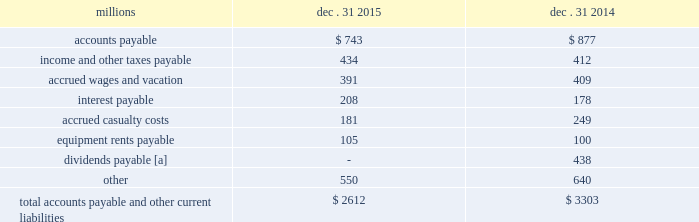Appropriate statistical bases .
Total expense for repairs and maintenance incurred was $ 2.5 billion for 2015 , $ 2.4 billion for 2014 , and $ 2.3 billion for 2013 .
Assets held under capital leases are recorded at the lower of the net present value of the minimum lease payments or the fair value of the leased asset at the inception of the lease .
Amortization expense is computed using the straight-line method over the shorter of the estimated useful lives of the assets or the period of the related lease .
13 .
Accounts payable and other current liabilities dec .
31 , dec .
31 , millions 2015 2014 .
[a] beginning in 2015 , the timing of the dividend declaration and payable dates was aligned to occur within the same quarter .
The 2015 dividends paid amount includes the fourth quarter 2014 dividend of $ 438 million , which was paid on january 2 , 2015 , the first quarter 2015 dividend of $ 484 million , which was paid on march 30 , 2015 , the second quarter 2015 dividend of $ 479 million , which was paid on june 30 , 2015 , the third quarter 2015 dividend of $ 476 million , which was paid on september 30 , 2015 , as well as the fourth quarter 2015 dividend of $ 467 million , which was paid on december 30 , 2015 .
14 .
Financial instruments strategy and risk 2013 we may use derivative financial instruments in limited instances for other than trading purposes to assist in managing our overall exposure to fluctuations in interest rates and fuel prices .
We are not a party to leveraged derivatives and , by policy , do not use derivative financial instruments for speculative purposes .
Derivative financial instruments qualifying for hedge accounting must maintain a specified level of effectiveness between the hedging instrument and the item being hedged , both at inception and throughout the hedged period .
We formally document the nature and relationships between the hedging instruments and hedged items at inception , as well as our risk- management objectives , strategies for undertaking the various hedge transactions , and method of assessing hedge effectiveness .
Changes in the fair market value of derivative financial instruments that do not qualify for hedge accounting are charged to earnings .
We may use swaps , collars , futures , and/or forward contracts to mitigate the risk of adverse movements in interest rates and fuel prices ; however , the use of these derivative financial instruments may limit future benefits from favorable interest rate and fuel price movements .
Market and credit risk 2013 we address market risk related to derivative financial instruments by selecting instruments with value fluctuations that highly correlate with the underlying hedged item .
We manage credit risk related to derivative financial instruments , which is minimal , by requiring high credit standards for counterparties and periodic settlements .
At december 31 , 2015 , and 2014 , we were not required to provide collateral , nor had we received collateral , relating to our hedging activities .
Interest rate fair value hedges 2013 we manage our overall exposure to fluctuations in interest rates by adjusting the proportion of fixed and floating rate debt instruments within our debt portfolio over a given period .
We generally manage the mix of fixed and floating rate debt through the issuance of targeted amounts of each as debt matures or as we require incremental borrowings .
We employ derivatives , primarily swaps , as one of the tools to obtain the targeted mix .
In addition , we also obtain flexibility in managing interest costs and the interest rate mix within our debt portfolio by evaluating the issuance of and managing outstanding callable fixed-rate debt securities .
Swaps allow us to convert debt from fixed rates to variable rates and thereby hedge the risk of changes in the debt 2019s fair value attributable to the changes in interest rates .
We account for swaps as fair value hedges using the short-cut method ; therefore , we do not record any ineffectiveness within our .
What was the percentage of the decline in the total accounts payable and other current liabilities from 2014 to 2015? 
Computations: ((2612 - 3303) / 3303)
Answer: -0.2092. 